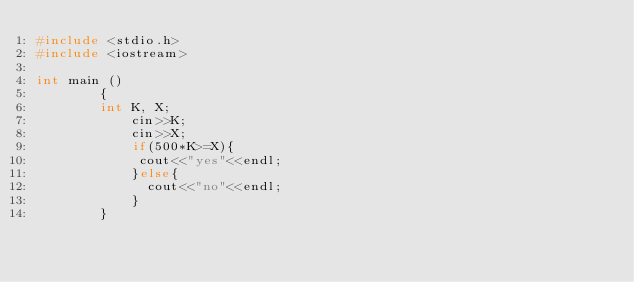<code> <loc_0><loc_0><loc_500><loc_500><_C++_>#include <stdio.h>
#include <iostream>      

int main ()
        {
        int K, X;
            cin>>K;
            cin>>X;
            if(500*K>=X){
             cout<<"yes"<<endl;
            }else{
              cout<<"no"<<endl;
            }
        }</code> 